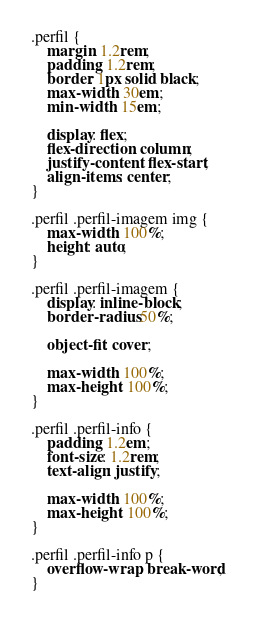Convert code to text. <code><loc_0><loc_0><loc_500><loc_500><_CSS_>.perfil {
    margin: 1.2rem;
    padding: 1.2rem;
    border: 1px solid black;
    max-width: 30em;
    min-width: 15em;
    
    display: flex;
    flex-direction: column;
    justify-content: flex-start;
    align-items: center;
}

.perfil .perfil-imagem img {
    max-width: 100%;
    height: auto;
}

.perfil .perfil-imagem {
    display: inline-block;
    border-radius: 50%;

    object-fit: cover;

    max-width: 100%;
    max-height: 100%;
}

.perfil .perfil-info {
    padding: 1.2em;
    font-size: 1.2rem;
    text-align: justify;

    max-width: 100%;
    max-height: 100%;
}

.perfil .perfil-info p {
    overflow-wrap: break-word;
}</code> 